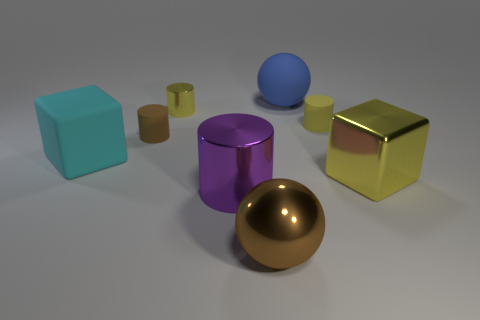There is a tiny cylinder that is the same color as the big metallic sphere; what material is it?
Your response must be concise. Rubber. There is a large ball that is in front of the large block that is to the right of the purple metal object; are there any metal blocks in front of it?
Provide a succinct answer. No. Is the material of the ball that is in front of the matte cube the same as the cylinder that is in front of the cyan cube?
Your answer should be compact. Yes. What number of things are brown matte cylinders or matte things on the right side of the tiny brown object?
Make the answer very short. 3. What number of brown matte things have the same shape as the small metallic thing?
Offer a very short reply. 1. What is the material of the yellow thing that is the same size as the brown metallic thing?
Provide a short and direct response. Metal. What is the size of the block right of the small matte cylinder that is on the left side of the thing that is behind the small yellow shiny object?
Your response must be concise. Large. There is a large cube that is in front of the cyan rubber thing; is it the same color as the shiny cylinder that is behind the big cyan matte object?
Offer a very short reply. Yes. How many brown objects are big metallic balls or metallic cylinders?
Your answer should be compact. 1. How many brown objects are the same size as the yellow block?
Your answer should be compact. 1. 